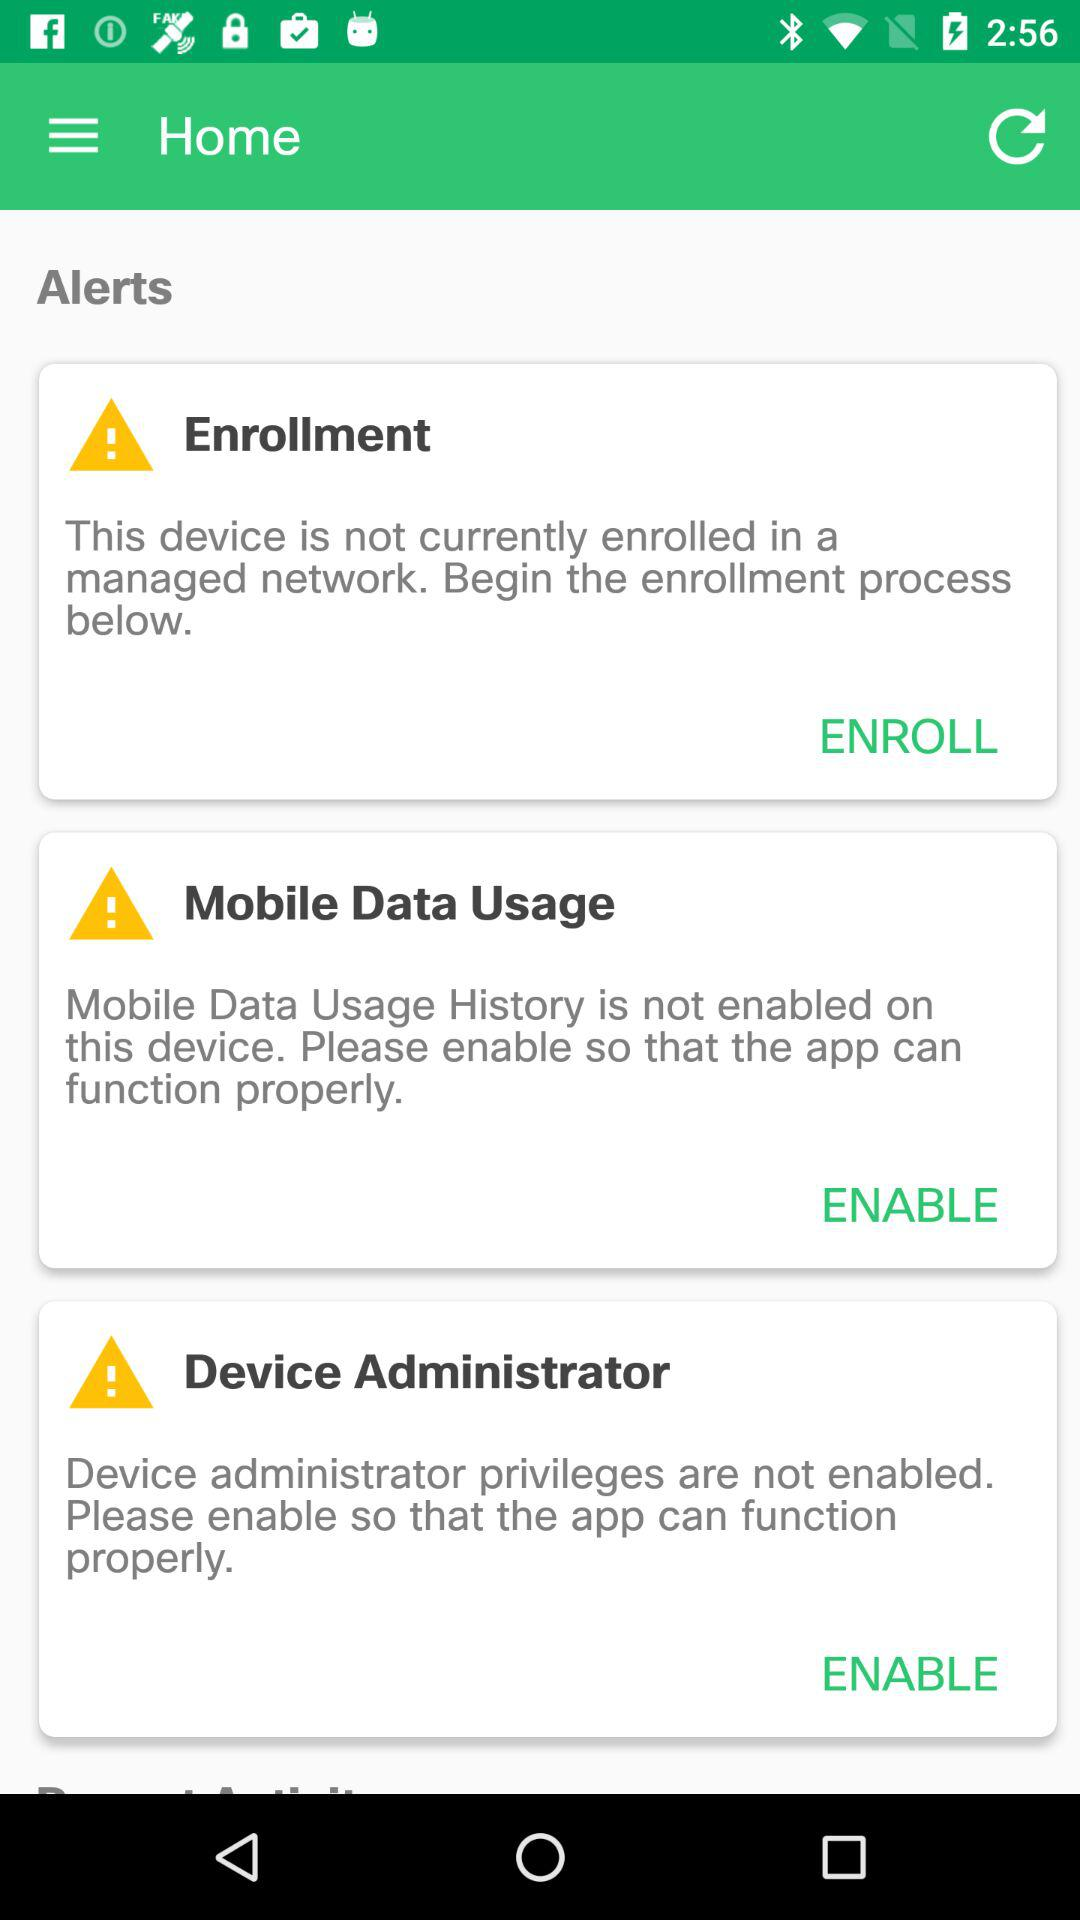How many alerts are there?
Answer the question using a single word or phrase. 3 